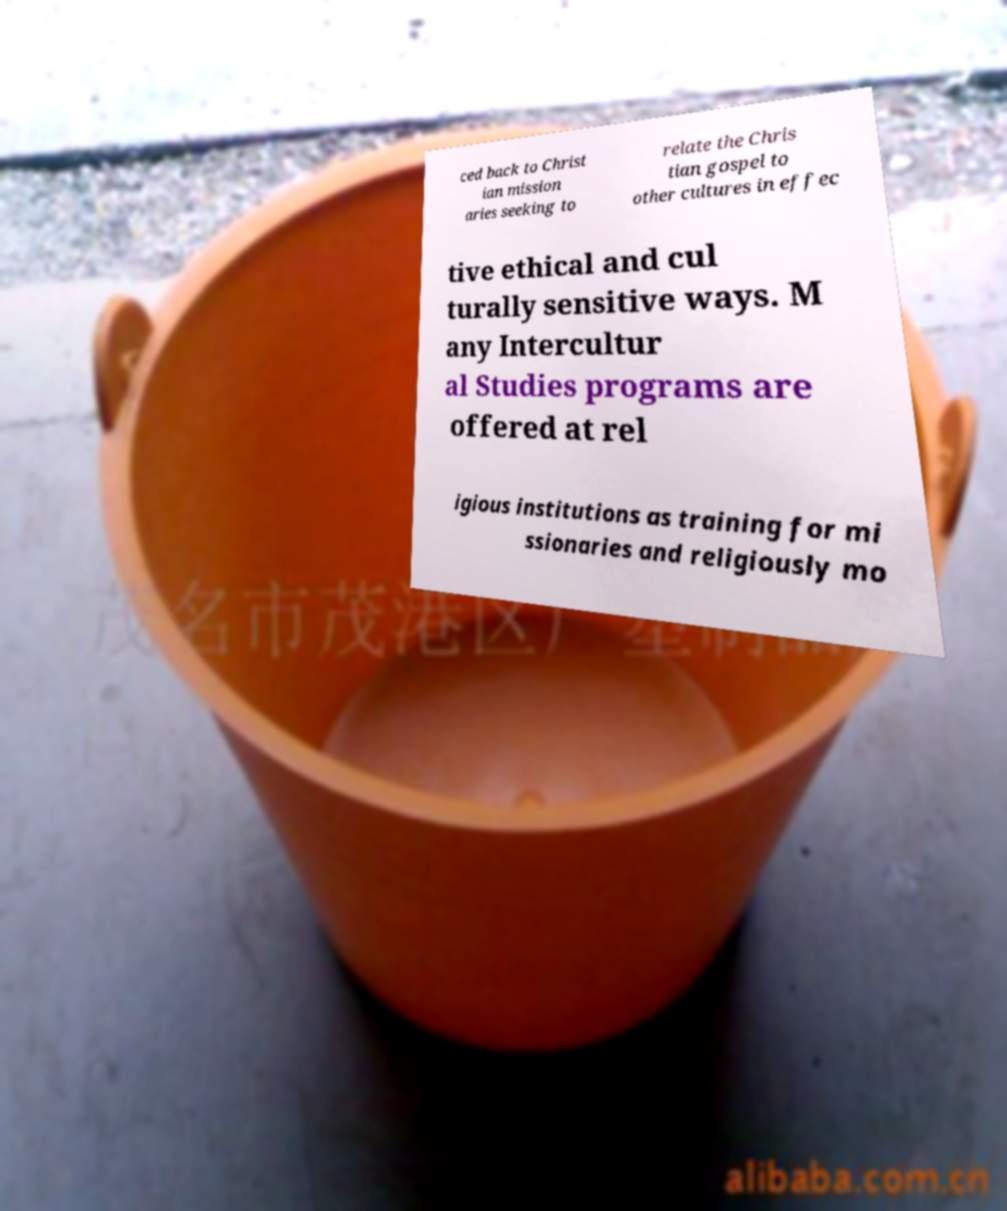Can you accurately transcribe the text from the provided image for me? ced back to Christ ian mission aries seeking to relate the Chris tian gospel to other cultures in effec tive ethical and cul turally sensitive ways. M any Intercultur al Studies programs are offered at rel igious institutions as training for mi ssionaries and religiously mo 